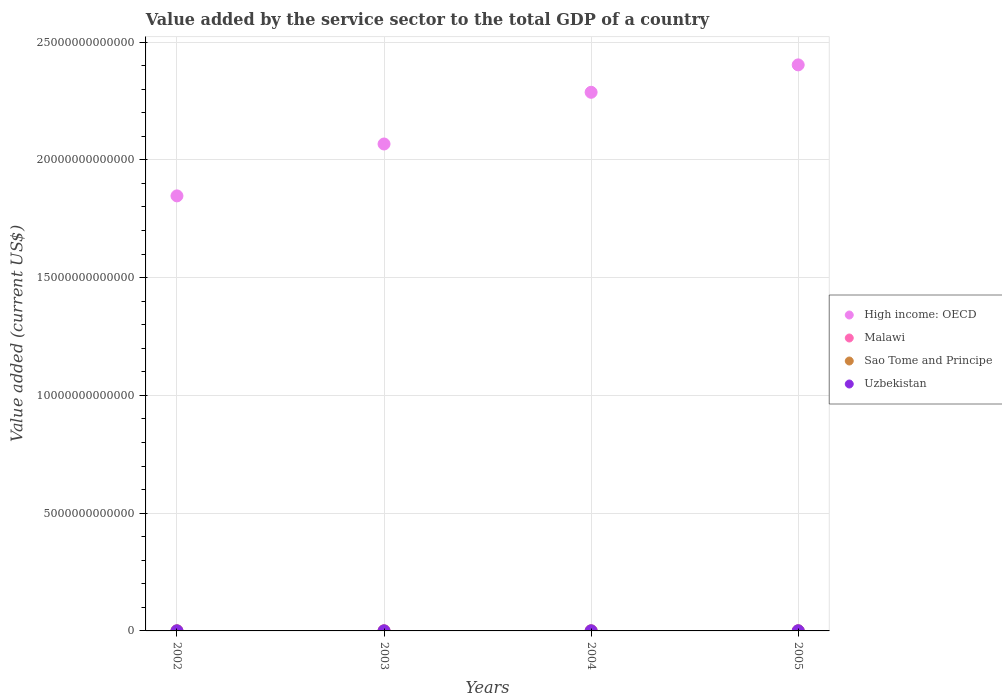What is the value added by the service sector to the total GDP in Uzbekistan in 2004?
Offer a very short reply. 4.47e+09. Across all years, what is the maximum value added by the service sector to the total GDP in Malawi?
Keep it short and to the point. 1.23e+09. Across all years, what is the minimum value added by the service sector to the total GDP in Malawi?
Give a very brief answer. 1.04e+09. What is the total value added by the service sector to the total GDP in Uzbekistan in the graph?
Keep it short and to the point. 1.82e+1. What is the difference between the value added by the service sector to the total GDP in Malawi in 2002 and that in 2005?
Provide a succinct answer. -4.09e+07. What is the difference between the value added by the service sector to the total GDP in High income: OECD in 2004 and the value added by the service sector to the total GDP in Sao Tome and Principe in 2002?
Make the answer very short. 2.29e+13. What is the average value added by the service sector to the total GDP in High income: OECD per year?
Provide a succinct answer. 2.15e+13. In the year 2004, what is the difference between the value added by the service sector to the total GDP in Sao Tome and Principe and value added by the service sector to the total GDP in High income: OECD?
Keep it short and to the point. -2.29e+13. What is the ratio of the value added by the service sector to the total GDP in Uzbekistan in 2004 to that in 2005?
Provide a short and direct response. 0.72. What is the difference between the highest and the second highest value added by the service sector to the total GDP in Malawi?
Your answer should be very brief. 4.09e+07. What is the difference between the highest and the lowest value added by the service sector to the total GDP in High income: OECD?
Provide a succinct answer. 5.56e+12. In how many years, is the value added by the service sector to the total GDP in Uzbekistan greater than the average value added by the service sector to the total GDP in Uzbekistan taken over all years?
Give a very brief answer. 1. Is the sum of the value added by the service sector to the total GDP in High income: OECD in 2002 and 2004 greater than the maximum value added by the service sector to the total GDP in Malawi across all years?
Your answer should be very brief. Yes. Is the value added by the service sector to the total GDP in Sao Tome and Principe strictly greater than the value added by the service sector to the total GDP in Malawi over the years?
Keep it short and to the point. No. How many years are there in the graph?
Your answer should be compact. 4. What is the difference between two consecutive major ticks on the Y-axis?
Offer a very short reply. 5.00e+12. Where does the legend appear in the graph?
Ensure brevity in your answer.  Center right. How are the legend labels stacked?
Your answer should be very brief. Vertical. What is the title of the graph?
Offer a terse response. Value added by the service sector to the total GDP of a country. What is the label or title of the X-axis?
Provide a succinct answer. Years. What is the label or title of the Y-axis?
Offer a very short reply. Value added (current US$). What is the Value added (current US$) in High income: OECD in 2002?
Your answer should be compact. 1.85e+13. What is the Value added (current US$) of Malawi in 2002?
Offer a very short reply. 1.19e+09. What is the Value added (current US$) in Sao Tome and Principe in 2002?
Offer a terse response. 4.94e+07. What is the Value added (current US$) of Uzbekistan in 2002?
Keep it short and to the point. 3.72e+09. What is the Value added (current US$) of High income: OECD in 2003?
Your response must be concise. 2.07e+13. What is the Value added (current US$) of Malawi in 2003?
Ensure brevity in your answer.  1.04e+09. What is the Value added (current US$) in Sao Tome and Principe in 2003?
Keep it short and to the point. 6.05e+07. What is the Value added (current US$) of Uzbekistan in 2003?
Your answer should be very brief. 3.79e+09. What is the Value added (current US$) of High income: OECD in 2004?
Offer a terse response. 2.29e+13. What is the Value added (current US$) of Malawi in 2004?
Offer a terse response. 1.13e+09. What is the Value added (current US$) of Sao Tome and Principe in 2004?
Ensure brevity in your answer.  6.72e+07. What is the Value added (current US$) of Uzbekistan in 2004?
Your response must be concise. 4.47e+09. What is the Value added (current US$) in High income: OECD in 2005?
Ensure brevity in your answer.  2.40e+13. What is the Value added (current US$) in Malawi in 2005?
Make the answer very short. 1.23e+09. What is the Value added (current US$) in Sao Tome and Principe in 2005?
Make the answer very short. 8.40e+07. What is the Value added (current US$) of Uzbekistan in 2005?
Offer a terse response. 6.25e+09. Across all years, what is the maximum Value added (current US$) in High income: OECD?
Your answer should be very brief. 2.40e+13. Across all years, what is the maximum Value added (current US$) of Malawi?
Provide a succinct answer. 1.23e+09. Across all years, what is the maximum Value added (current US$) in Sao Tome and Principe?
Your answer should be compact. 8.40e+07. Across all years, what is the maximum Value added (current US$) in Uzbekistan?
Your answer should be compact. 6.25e+09. Across all years, what is the minimum Value added (current US$) in High income: OECD?
Keep it short and to the point. 1.85e+13. Across all years, what is the minimum Value added (current US$) of Malawi?
Keep it short and to the point. 1.04e+09. Across all years, what is the minimum Value added (current US$) of Sao Tome and Principe?
Make the answer very short. 4.94e+07. Across all years, what is the minimum Value added (current US$) in Uzbekistan?
Provide a short and direct response. 3.72e+09. What is the total Value added (current US$) in High income: OECD in the graph?
Your response must be concise. 8.60e+13. What is the total Value added (current US$) of Malawi in the graph?
Provide a succinct answer. 4.58e+09. What is the total Value added (current US$) of Sao Tome and Principe in the graph?
Make the answer very short. 2.61e+08. What is the total Value added (current US$) of Uzbekistan in the graph?
Make the answer very short. 1.82e+1. What is the difference between the Value added (current US$) in High income: OECD in 2002 and that in 2003?
Your response must be concise. -2.20e+12. What is the difference between the Value added (current US$) of Malawi in 2002 and that in 2003?
Offer a terse response. 1.46e+08. What is the difference between the Value added (current US$) of Sao Tome and Principe in 2002 and that in 2003?
Your answer should be compact. -1.11e+07. What is the difference between the Value added (current US$) of Uzbekistan in 2002 and that in 2003?
Provide a short and direct response. -6.96e+07. What is the difference between the Value added (current US$) of High income: OECD in 2002 and that in 2004?
Your answer should be very brief. -4.40e+12. What is the difference between the Value added (current US$) of Malawi in 2002 and that in 2004?
Keep it short and to the point. 5.48e+07. What is the difference between the Value added (current US$) in Sao Tome and Principe in 2002 and that in 2004?
Ensure brevity in your answer.  -1.79e+07. What is the difference between the Value added (current US$) in Uzbekistan in 2002 and that in 2004?
Offer a terse response. -7.49e+08. What is the difference between the Value added (current US$) of High income: OECD in 2002 and that in 2005?
Make the answer very short. -5.56e+12. What is the difference between the Value added (current US$) in Malawi in 2002 and that in 2005?
Keep it short and to the point. -4.09e+07. What is the difference between the Value added (current US$) of Sao Tome and Principe in 2002 and that in 2005?
Your answer should be compact. -3.46e+07. What is the difference between the Value added (current US$) of Uzbekistan in 2002 and that in 2005?
Offer a very short reply. -2.53e+09. What is the difference between the Value added (current US$) in High income: OECD in 2003 and that in 2004?
Provide a short and direct response. -2.19e+12. What is the difference between the Value added (current US$) of Malawi in 2003 and that in 2004?
Give a very brief answer. -9.16e+07. What is the difference between the Value added (current US$) of Sao Tome and Principe in 2003 and that in 2004?
Your answer should be very brief. -6.75e+06. What is the difference between the Value added (current US$) of Uzbekistan in 2003 and that in 2004?
Keep it short and to the point. -6.80e+08. What is the difference between the Value added (current US$) in High income: OECD in 2003 and that in 2005?
Offer a very short reply. -3.36e+12. What is the difference between the Value added (current US$) of Malawi in 2003 and that in 2005?
Offer a very short reply. -1.87e+08. What is the difference between the Value added (current US$) of Sao Tome and Principe in 2003 and that in 2005?
Provide a succinct answer. -2.35e+07. What is the difference between the Value added (current US$) in Uzbekistan in 2003 and that in 2005?
Ensure brevity in your answer.  -2.46e+09. What is the difference between the Value added (current US$) of High income: OECD in 2004 and that in 2005?
Offer a terse response. -1.16e+12. What is the difference between the Value added (current US$) in Malawi in 2004 and that in 2005?
Your response must be concise. -9.58e+07. What is the difference between the Value added (current US$) in Sao Tome and Principe in 2004 and that in 2005?
Your response must be concise. -1.68e+07. What is the difference between the Value added (current US$) in Uzbekistan in 2004 and that in 2005?
Ensure brevity in your answer.  -1.78e+09. What is the difference between the Value added (current US$) of High income: OECD in 2002 and the Value added (current US$) of Malawi in 2003?
Offer a very short reply. 1.85e+13. What is the difference between the Value added (current US$) of High income: OECD in 2002 and the Value added (current US$) of Sao Tome and Principe in 2003?
Provide a succinct answer. 1.85e+13. What is the difference between the Value added (current US$) in High income: OECD in 2002 and the Value added (current US$) in Uzbekistan in 2003?
Provide a succinct answer. 1.85e+13. What is the difference between the Value added (current US$) of Malawi in 2002 and the Value added (current US$) of Sao Tome and Principe in 2003?
Your response must be concise. 1.13e+09. What is the difference between the Value added (current US$) in Malawi in 2002 and the Value added (current US$) in Uzbekistan in 2003?
Give a very brief answer. -2.61e+09. What is the difference between the Value added (current US$) of Sao Tome and Principe in 2002 and the Value added (current US$) of Uzbekistan in 2003?
Keep it short and to the point. -3.74e+09. What is the difference between the Value added (current US$) of High income: OECD in 2002 and the Value added (current US$) of Malawi in 2004?
Your answer should be compact. 1.85e+13. What is the difference between the Value added (current US$) in High income: OECD in 2002 and the Value added (current US$) in Sao Tome and Principe in 2004?
Ensure brevity in your answer.  1.85e+13. What is the difference between the Value added (current US$) in High income: OECD in 2002 and the Value added (current US$) in Uzbekistan in 2004?
Provide a succinct answer. 1.85e+13. What is the difference between the Value added (current US$) of Malawi in 2002 and the Value added (current US$) of Sao Tome and Principe in 2004?
Your response must be concise. 1.12e+09. What is the difference between the Value added (current US$) in Malawi in 2002 and the Value added (current US$) in Uzbekistan in 2004?
Make the answer very short. -3.29e+09. What is the difference between the Value added (current US$) in Sao Tome and Principe in 2002 and the Value added (current US$) in Uzbekistan in 2004?
Give a very brief answer. -4.42e+09. What is the difference between the Value added (current US$) of High income: OECD in 2002 and the Value added (current US$) of Malawi in 2005?
Make the answer very short. 1.85e+13. What is the difference between the Value added (current US$) of High income: OECD in 2002 and the Value added (current US$) of Sao Tome and Principe in 2005?
Your response must be concise. 1.85e+13. What is the difference between the Value added (current US$) of High income: OECD in 2002 and the Value added (current US$) of Uzbekistan in 2005?
Your answer should be very brief. 1.85e+13. What is the difference between the Value added (current US$) of Malawi in 2002 and the Value added (current US$) of Sao Tome and Principe in 2005?
Offer a very short reply. 1.10e+09. What is the difference between the Value added (current US$) in Malawi in 2002 and the Value added (current US$) in Uzbekistan in 2005?
Your answer should be very brief. -5.06e+09. What is the difference between the Value added (current US$) in Sao Tome and Principe in 2002 and the Value added (current US$) in Uzbekistan in 2005?
Make the answer very short. -6.20e+09. What is the difference between the Value added (current US$) in High income: OECD in 2003 and the Value added (current US$) in Malawi in 2004?
Your response must be concise. 2.07e+13. What is the difference between the Value added (current US$) of High income: OECD in 2003 and the Value added (current US$) of Sao Tome and Principe in 2004?
Offer a terse response. 2.07e+13. What is the difference between the Value added (current US$) in High income: OECD in 2003 and the Value added (current US$) in Uzbekistan in 2004?
Ensure brevity in your answer.  2.07e+13. What is the difference between the Value added (current US$) of Malawi in 2003 and the Value added (current US$) of Sao Tome and Principe in 2004?
Make the answer very short. 9.72e+08. What is the difference between the Value added (current US$) of Malawi in 2003 and the Value added (current US$) of Uzbekistan in 2004?
Offer a terse response. -3.43e+09. What is the difference between the Value added (current US$) in Sao Tome and Principe in 2003 and the Value added (current US$) in Uzbekistan in 2004?
Ensure brevity in your answer.  -4.41e+09. What is the difference between the Value added (current US$) in High income: OECD in 2003 and the Value added (current US$) in Malawi in 2005?
Provide a succinct answer. 2.07e+13. What is the difference between the Value added (current US$) of High income: OECD in 2003 and the Value added (current US$) of Sao Tome and Principe in 2005?
Ensure brevity in your answer.  2.07e+13. What is the difference between the Value added (current US$) of High income: OECD in 2003 and the Value added (current US$) of Uzbekistan in 2005?
Make the answer very short. 2.07e+13. What is the difference between the Value added (current US$) in Malawi in 2003 and the Value added (current US$) in Sao Tome and Principe in 2005?
Keep it short and to the point. 9.55e+08. What is the difference between the Value added (current US$) of Malawi in 2003 and the Value added (current US$) of Uzbekistan in 2005?
Offer a very short reply. -5.21e+09. What is the difference between the Value added (current US$) of Sao Tome and Principe in 2003 and the Value added (current US$) of Uzbekistan in 2005?
Provide a succinct answer. -6.19e+09. What is the difference between the Value added (current US$) of High income: OECD in 2004 and the Value added (current US$) of Malawi in 2005?
Offer a terse response. 2.29e+13. What is the difference between the Value added (current US$) in High income: OECD in 2004 and the Value added (current US$) in Sao Tome and Principe in 2005?
Make the answer very short. 2.29e+13. What is the difference between the Value added (current US$) in High income: OECD in 2004 and the Value added (current US$) in Uzbekistan in 2005?
Ensure brevity in your answer.  2.29e+13. What is the difference between the Value added (current US$) in Malawi in 2004 and the Value added (current US$) in Sao Tome and Principe in 2005?
Offer a terse response. 1.05e+09. What is the difference between the Value added (current US$) of Malawi in 2004 and the Value added (current US$) of Uzbekistan in 2005?
Give a very brief answer. -5.12e+09. What is the difference between the Value added (current US$) of Sao Tome and Principe in 2004 and the Value added (current US$) of Uzbekistan in 2005?
Provide a short and direct response. -6.18e+09. What is the average Value added (current US$) of High income: OECD per year?
Ensure brevity in your answer.  2.15e+13. What is the average Value added (current US$) in Malawi per year?
Offer a very short reply. 1.15e+09. What is the average Value added (current US$) in Sao Tome and Principe per year?
Ensure brevity in your answer.  6.53e+07. What is the average Value added (current US$) of Uzbekistan per year?
Make the answer very short. 4.56e+09. In the year 2002, what is the difference between the Value added (current US$) of High income: OECD and Value added (current US$) of Malawi?
Make the answer very short. 1.85e+13. In the year 2002, what is the difference between the Value added (current US$) of High income: OECD and Value added (current US$) of Sao Tome and Principe?
Offer a terse response. 1.85e+13. In the year 2002, what is the difference between the Value added (current US$) of High income: OECD and Value added (current US$) of Uzbekistan?
Ensure brevity in your answer.  1.85e+13. In the year 2002, what is the difference between the Value added (current US$) of Malawi and Value added (current US$) of Sao Tome and Principe?
Offer a very short reply. 1.14e+09. In the year 2002, what is the difference between the Value added (current US$) of Malawi and Value added (current US$) of Uzbekistan?
Your answer should be compact. -2.54e+09. In the year 2002, what is the difference between the Value added (current US$) in Sao Tome and Principe and Value added (current US$) in Uzbekistan?
Provide a short and direct response. -3.67e+09. In the year 2003, what is the difference between the Value added (current US$) in High income: OECD and Value added (current US$) in Malawi?
Keep it short and to the point. 2.07e+13. In the year 2003, what is the difference between the Value added (current US$) in High income: OECD and Value added (current US$) in Sao Tome and Principe?
Your answer should be very brief. 2.07e+13. In the year 2003, what is the difference between the Value added (current US$) of High income: OECD and Value added (current US$) of Uzbekistan?
Offer a very short reply. 2.07e+13. In the year 2003, what is the difference between the Value added (current US$) of Malawi and Value added (current US$) of Sao Tome and Principe?
Make the answer very short. 9.79e+08. In the year 2003, what is the difference between the Value added (current US$) of Malawi and Value added (current US$) of Uzbekistan?
Make the answer very short. -2.75e+09. In the year 2003, what is the difference between the Value added (current US$) of Sao Tome and Principe and Value added (current US$) of Uzbekistan?
Give a very brief answer. -3.73e+09. In the year 2004, what is the difference between the Value added (current US$) of High income: OECD and Value added (current US$) of Malawi?
Offer a terse response. 2.29e+13. In the year 2004, what is the difference between the Value added (current US$) in High income: OECD and Value added (current US$) in Sao Tome and Principe?
Provide a short and direct response. 2.29e+13. In the year 2004, what is the difference between the Value added (current US$) in High income: OECD and Value added (current US$) in Uzbekistan?
Provide a succinct answer. 2.29e+13. In the year 2004, what is the difference between the Value added (current US$) in Malawi and Value added (current US$) in Sao Tome and Principe?
Give a very brief answer. 1.06e+09. In the year 2004, what is the difference between the Value added (current US$) of Malawi and Value added (current US$) of Uzbekistan?
Offer a terse response. -3.34e+09. In the year 2004, what is the difference between the Value added (current US$) in Sao Tome and Principe and Value added (current US$) in Uzbekistan?
Offer a terse response. -4.41e+09. In the year 2005, what is the difference between the Value added (current US$) in High income: OECD and Value added (current US$) in Malawi?
Provide a succinct answer. 2.40e+13. In the year 2005, what is the difference between the Value added (current US$) in High income: OECD and Value added (current US$) in Sao Tome and Principe?
Give a very brief answer. 2.40e+13. In the year 2005, what is the difference between the Value added (current US$) in High income: OECD and Value added (current US$) in Uzbekistan?
Give a very brief answer. 2.40e+13. In the year 2005, what is the difference between the Value added (current US$) of Malawi and Value added (current US$) of Sao Tome and Principe?
Your answer should be very brief. 1.14e+09. In the year 2005, what is the difference between the Value added (current US$) of Malawi and Value added (current US$) of Uzbekistan?
Your response must be concise. -5.02e+09. In the year 2005, what is the difference between the Value added (current US$) of Sao Tome and Principe and Value added (current US$) of Uzbekistan?
Provide a short and direct response. -6.17e+09. What is the ratio of the Value added (current US$) of High income: OECD in 2002 to that in 2003?
Your answer should be very brief. 0.89. What is the ratio of the Value added (current US$) of Malawi in 2002 to that in 2003?
Make the answer very short. 1.14. What is the ratio of the Value added (current US$) in Sao Tome and Principe in 2002 to that in 2003?
Provide a short and direct response. 0.82. What is the ratio of the Value added (current US$) of Uzbekistan in 2002 to that in 2003?
Provide a short and direct response. 0.98. What is the ratio of the Value added (current US$) of High income: OECD in 2002 to that in 2004?
Provide a succinct answer. 0.81. What is the ratio of the Value added (current US$) in Malawi in 2002 to that in 2004?
Your answer should be compact. 1.05. What is the ratio of the Value added (current US$) of Sao Tome and Principe in 2002 to that in 2004?
Your response must be concise. 0.73. What is the ratio of the Value added (current US$) of Uzbekistan in 2002 to that in 2004?
Your answer should be very brief. 0.83. What is the ratio of the Value added (current US$) of High income: OECD in 2002 to that in 2005?
Ensure brevity in your answer.  0.77. What is the ratio of the Value added (current US$) of Malawi in 2002 to that in 2005?
Your answer should be very brief. 0.97. What is the ratio of the Value added (current US$) in Sao Tome and Principe in 2002 to that in 2005?
Your answer should be compact. 0.59. What is the ratio of the Value added (current US$) in Uzbekistan in 2002 to that in 2005?
Your answer should be very brief. 0.6. What is the ratio of the Value added (current US$) of High income: OECD in 2003 to that in 2004?
Make the answer very short. 0.9. What is the ratio of the Value added (current US$) of Malawi in 2003 to that in 2004?
Keep it short and to the point. 0.92. What is the ratio of the Value added (current US$) in Sao Tome and Principe in 2003 to that in 2004?
Provide a succinct answer. 0.9. What is the ratio of the Value added (current US$) in Uzbekistan in 2003 to that in 2004?
Your response must be concise. 0.85. What is the ratio of the Value added (current US$) in High income: OECD in 2003 to that in 2005?
Give a very brief answer. 0.86. What is the ratio of the Value added (current US$) in Malawi in 2003 to that in 2005?
Your answer should be very brief. 0.85. What is the ratio of the Value added (current US$) in Sao Tome and Principe in 2003 to that in 2005?
Keep it short and to the point. 0.72. What is the ratio of the Value added (current US$) of Uzbekistan in 2003 to that in 2005?
Provide a short and direct response. 0.61. What is the ratio of the Value added (current US$) of High income: OECD in 2004 to that in 2005?
Give a very brief answer. 0.95. What is the ratio of the Value added (current US$) in Malawi in 2004 to that in 2005?
Ensure brevity in your answer.  0.92. What is the ratio of the Value added (current US$) of Sao Tome and Principe in 2004 to that in 2005?
Offer a very short reply. 0.8. What is the ratio of the Value added (current US$) in Uzbekistan in 2004 to that in 2005?
Make the answer very short. 0.72. What is the difference between the highest and the second highest Value added (current US$) of High income: OECD?
Provide a short and direct response. 1.16e+12. What is the difference between the highest and the second highest Value added (current US$) in Malawi?
Offer a very short reply. 4.09e+07. What is the difference between the highest and the second highest Value added (current US$) in Sao Tome and Principe?
Offer a terse response. 1.68e+07. What is the difference between the highest and the second highest Value added (current US$) of Uzbekistan?
Provide a succinct answer. 1.78e+09. What is the difference between the highest and the lowest Value added (current US$) in High income: OECD?
Offer a terse response. 5.56e+12. What is the difference between the highest and the lowest Value added (current US$) in Malawi?
Your response must be concise. 1.87e+08. What is the difference between the highest and the lowest Value added (current US$) in Sao Tome and Principe?
Offer a terse response. 3.46e+07. What is the difference between the highest and the lowest Value added (current US$) in Uzbekistan?
Offer a terse response. 2.53e+09. 